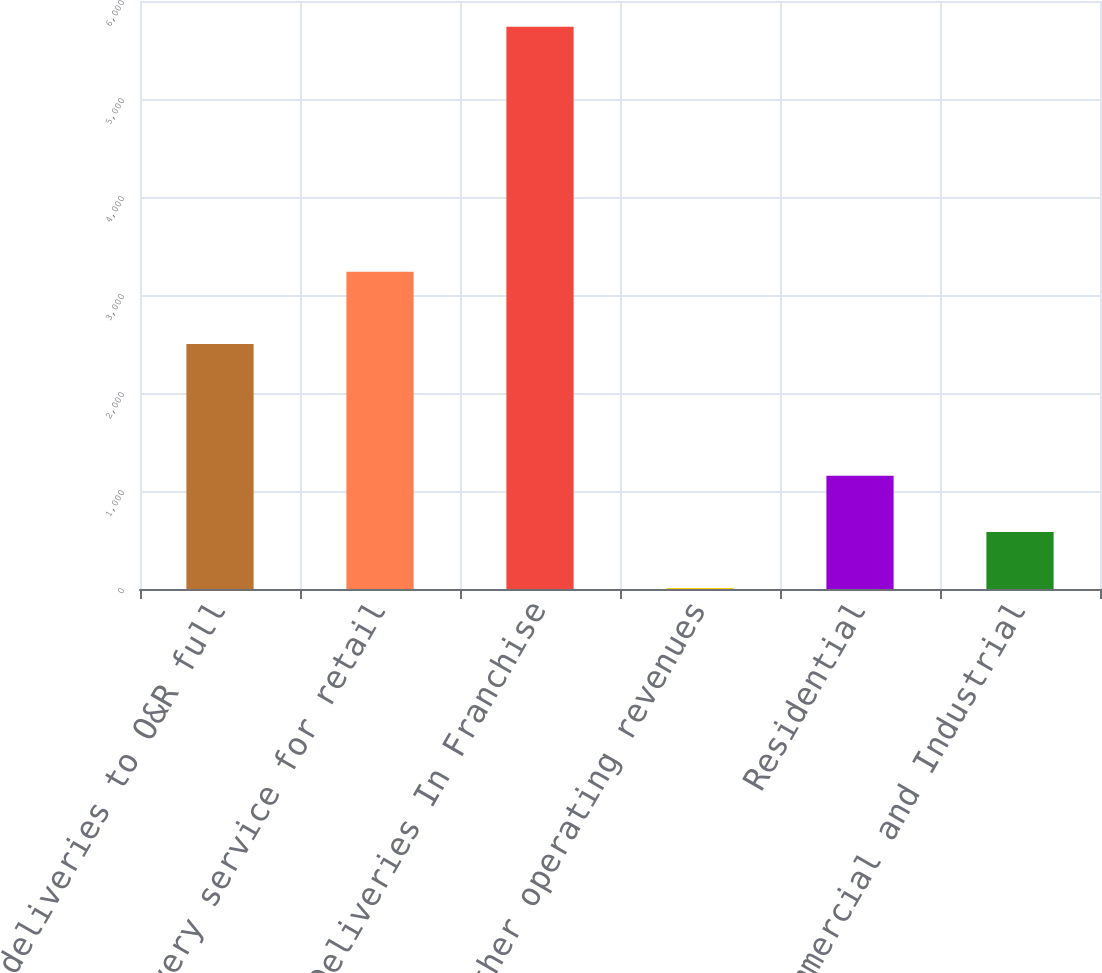<chart> <loc_0><loc_0><loc_500><loc_500><bar_chart><fcel>Total deliveries to O&R full<fcel>Delivery service for retail<fcel>Total Deliveries In Franchise<fcel>Other operating revenues<fcel>Residential<fcel>Commercial and Industrial<nl><fcel>2499<fcel>3237<fcel>5736<fcel>9<fcel>1154.4<fcel>581.7<nl></chart> 